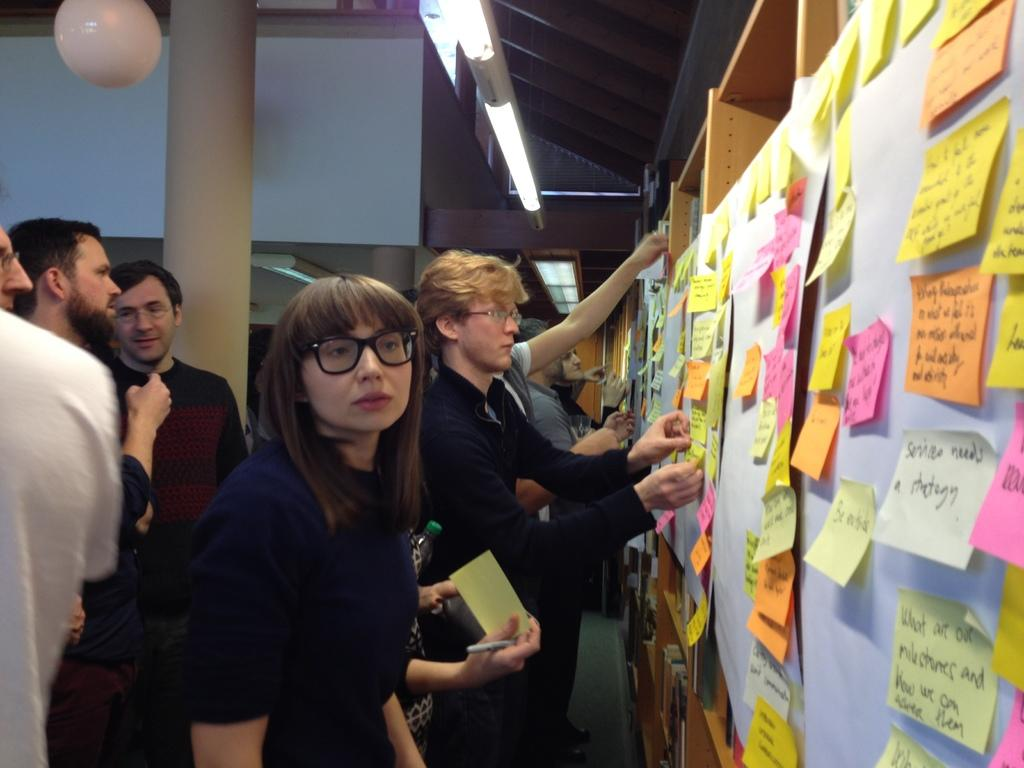How many people are in the image? There are many persons in the image. What are the persons doing in the image? The persons are pasting papers on a board. Where is the board located in the image? The board is located to the right in the image. What can be seen in the background of the image? There is a wall and a pillar in the background of the image. What month is it in the image? The month cannot be determined from the image, as there is no information about the time or date. 